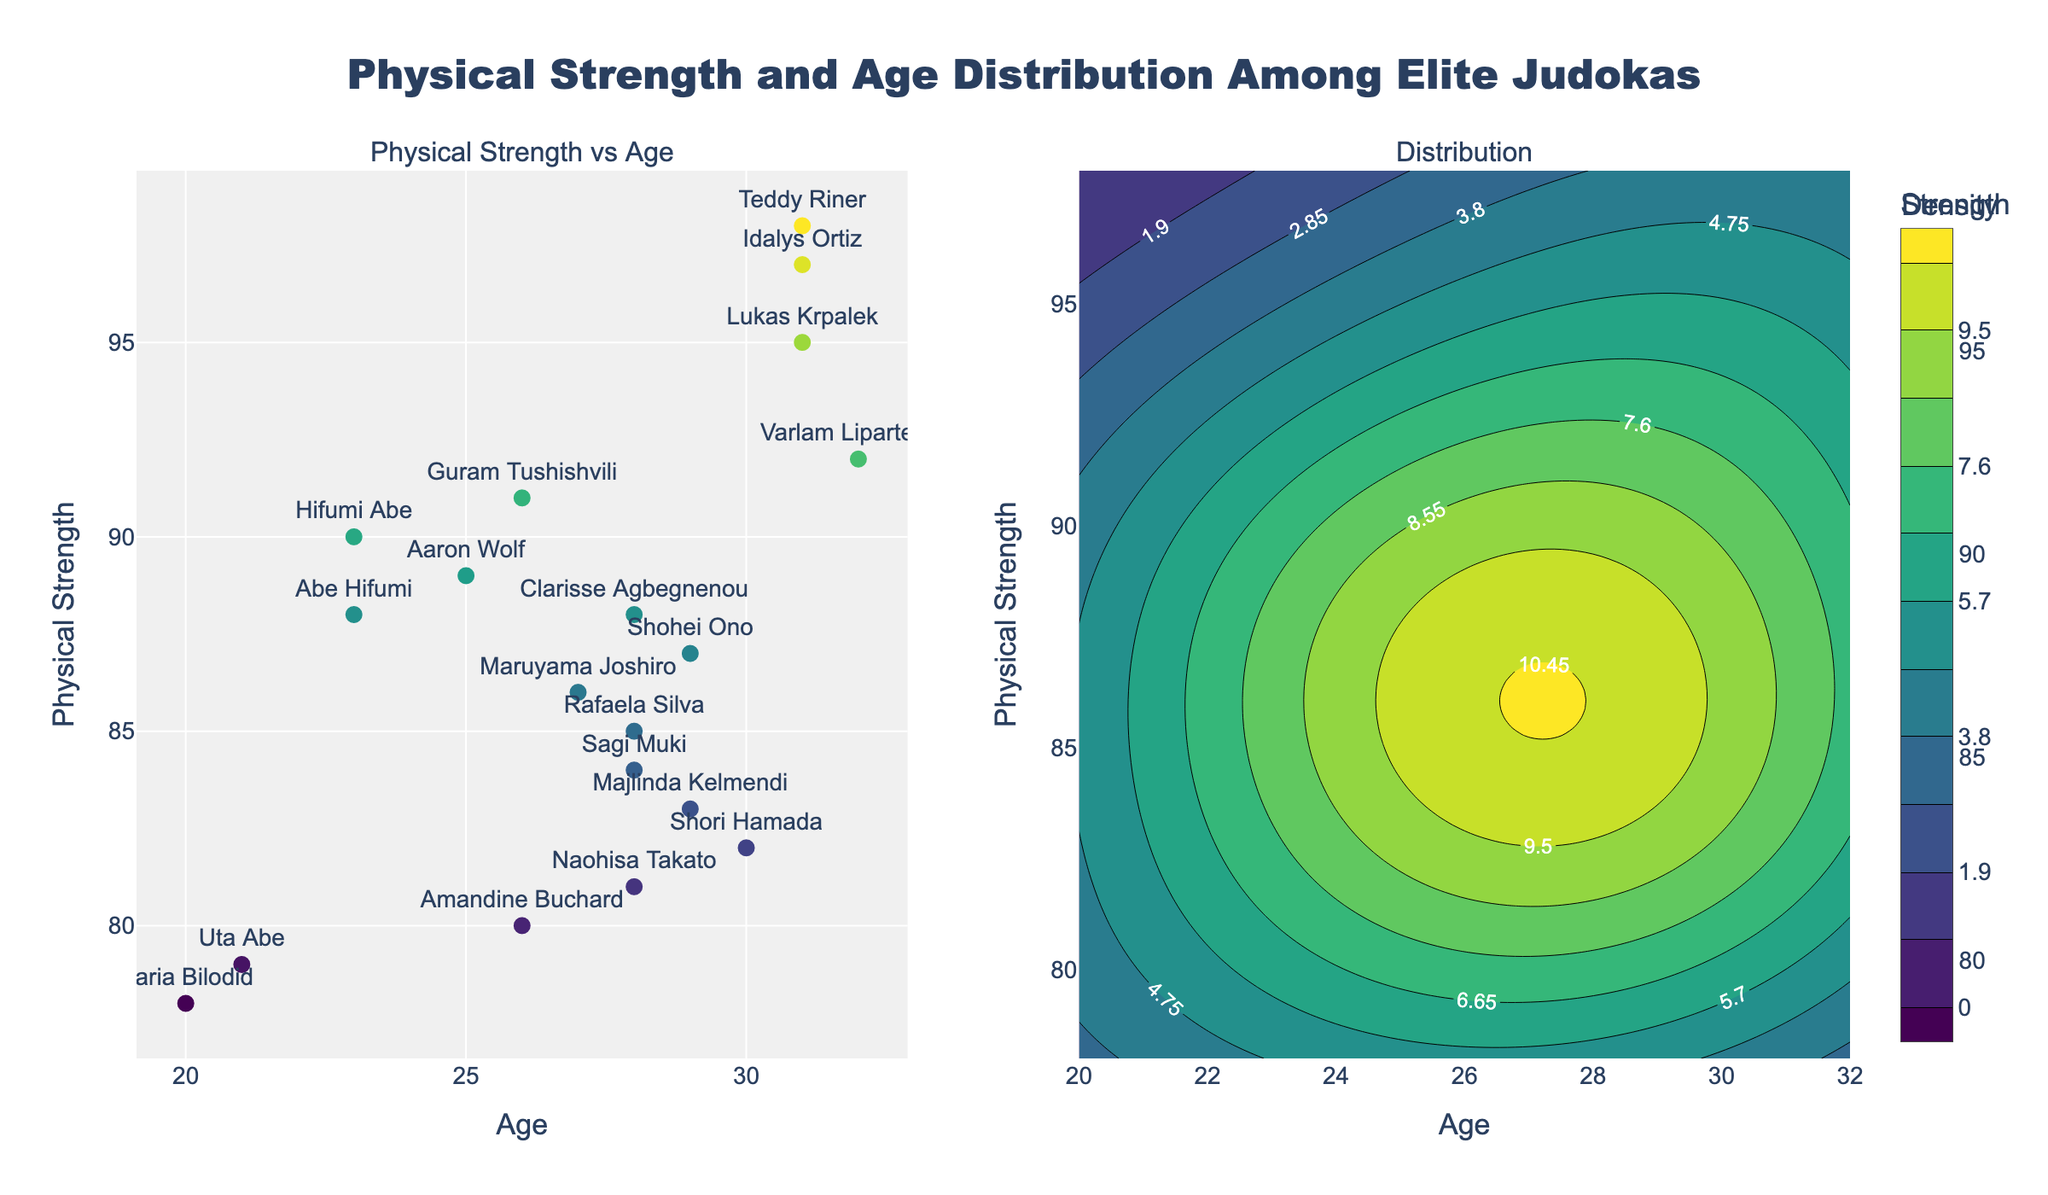What's the title of the figure? The title is located at the top of the figure, clearly displayed in a large font.
Answer: Physical Strength and Age Distribution Among Elite Judokas What is the age of the judoka with the highest physical strength? Look for the data point in the scatter plot with the largest y-value, representing physical strength. Hover over or read the labels to determine the corresponding age.
Answer: 31 What is the average physical strength of the judokas who are younger than 25? Identify the data points where the age is less than 25. Sum their physical strength values and divide by the number of such judokas. The judokas meeting this criterion are Hifumi Abe (90), Daria Bilodid (78), Uta Abe (79), and Abe Hifumi (88). (90 + 78 + 79 + 88) / 4 = 83.75.
Answer: 83.75 Which judoka appears twice in the scatter plot, and what are their physical strength and ages? Look for any names that occur more than once in the scatter plot. Hover over the points to get their physical strength and age details.
Answer: Abe Hifumi, 88 at age 23 What is the general trend between age and physical strength in the scatter plot? Observe the placement of data points in the scatter plot with respect to age and physical strength. There is no strict trend, but there are more points with higher strength around the late 20s and early 30s ages.
Answer: No strict trend, with more points of higher strength in late 20s and early 30s What is the most common age range among the elite judokas based on the contour plot? Observe the contour plot on the right. The highest density regions (with the darkest colors) indicate the most common age ranges.
Answer: Late 20s to early 30s Which judoka has the closest physical strength to the average value of all judokas? Calculate the average physical strength of all judokas. Sum all physical strength values and divide by the number of data points. Check the scatter plot to find the closest value to this average. Average = (98 + 81 + 87 + 88 + 85 + 90 + 78 + 95 + 79 + 89 + 83 + 92 + 86 + 91 + 80 + 84 + 82 + 97 + 88)/19 ≈ 87. The closest value to 87 is Shohei Ono (87).
Answer: Shohei Ono How does the physical strength distribution vary with age based on the contour plot? Look at the contour plot to see how the density of points changes across different age ranges. More intense coloring indicates higher density.
Answer: Higher density around ages 25-32 with varying strength Which judoka has the lowest physical strength, and what is their age? Identify the lowest y-value on the scatter plot, which represents physical strength. Hover over or read the label to get the corresponding name and age.
Answer: Daria Bilodid, 20 